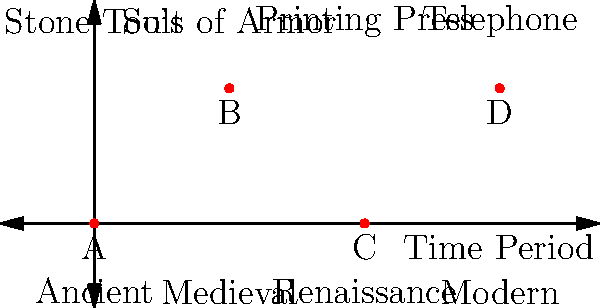Match the artifacts (A, B, C, D) to their correct time periods based on the visual cues provided in the diagram. Which artifact corresponds to the Renaissance period? To answer this question, we need to analyze the diagram and match the artifacts to their corresponding time periods:

1. The x-axis represents different time periods: Ancient, Medieval, Renaissance, and Modern.
2. Above each time period, there's a label indicating a representative artifact for that era.
3. The red dots (A, B, C, D) represent the artifacts we need to match.

Let's match each artifact:

A: Located at (0,0), corresponding to the Ancient period. The label above is "Stone Tools," which fits this era.
B: Located at (1,1), corresponding to the Medieval period. The label above is "Suit of Armor," which is characteristic of this time.
C: Located at (2,0), corresponding to the Renaissance period. The label above is "Printing Press," a revolutionary invention of the Renaissance.
D: Located at (3,1), corresponding to the Modern period. The label above is "Telephone," a modern invention.

The question asks specifically about the Renaissance period, which is represented by artifact C.
Answer: C 